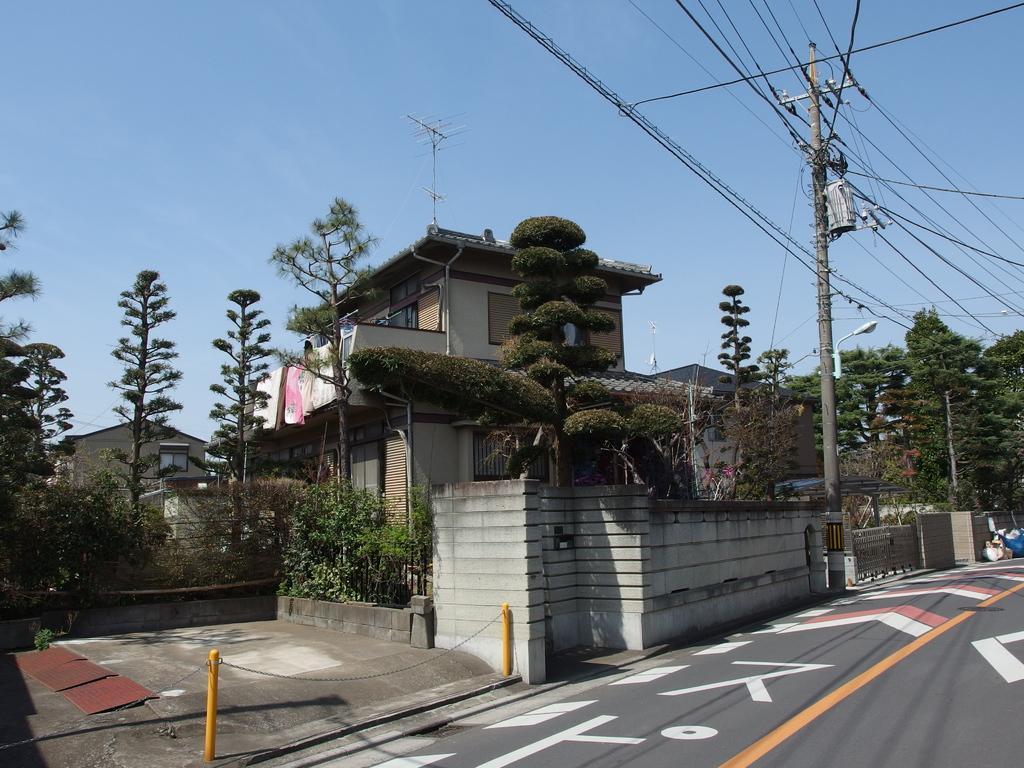In one or two sentences, can you explain what this image depicts? In this image, there are a few buildings. We can see some trees and plants. We can see some poles and chains. We can see the ground. We can see some objects on the right. We can see some wires. We can see the sky and some clothes. 